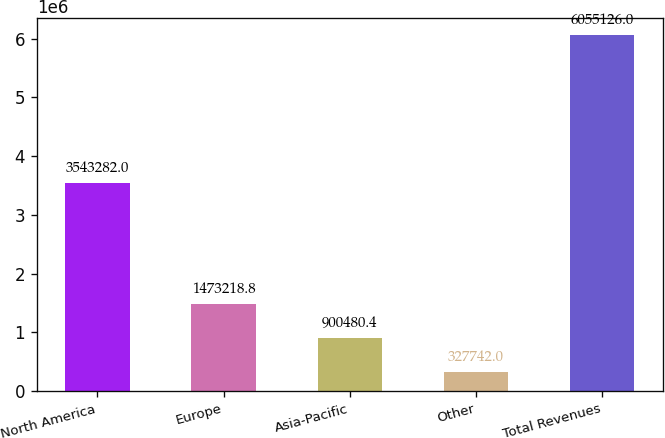<chart> <loc_0><loc_0><loc_500><loc_500><bar_chart><fcel>North America<fcel>Europe<fcel>Asia-Pacific<fcel>Other<fcel>Total Revenues<nl><fcel>3.54328e+06<fcel>1.47322e+06<fcel>900480<fcel>327742<fcel>6.05513e+06<nl></chart> 